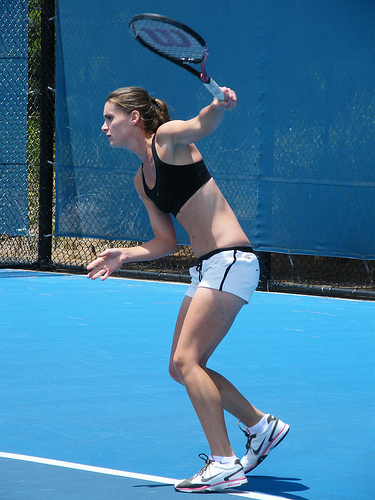Can you describe the attire the player is wearing? The player is dressed in athletic attire suitable for tennis, consisting of a dark tank top and white shorts, complemented with sports shoes to enhance performance and comfort during the game. 